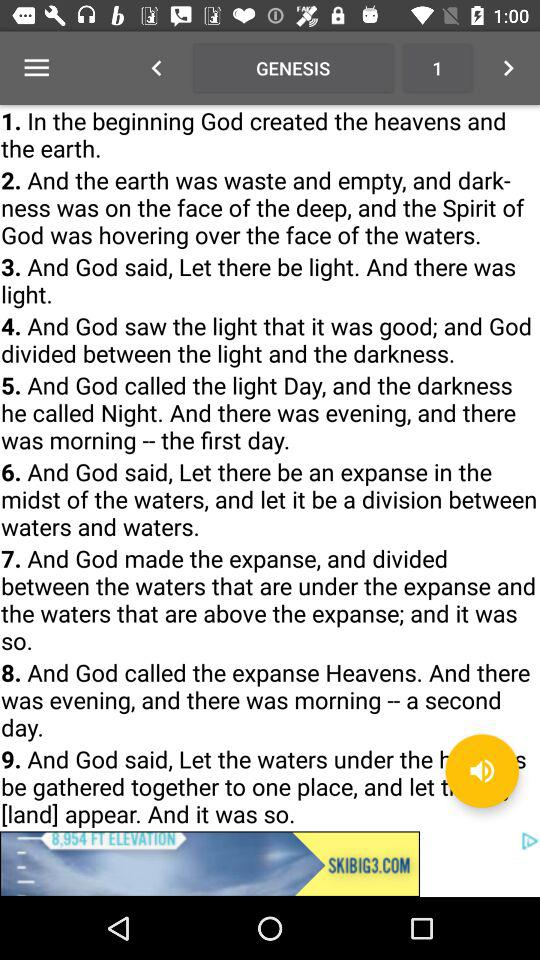What chapter number of "GENESIS" is shown? The shown chapter number is 1. 